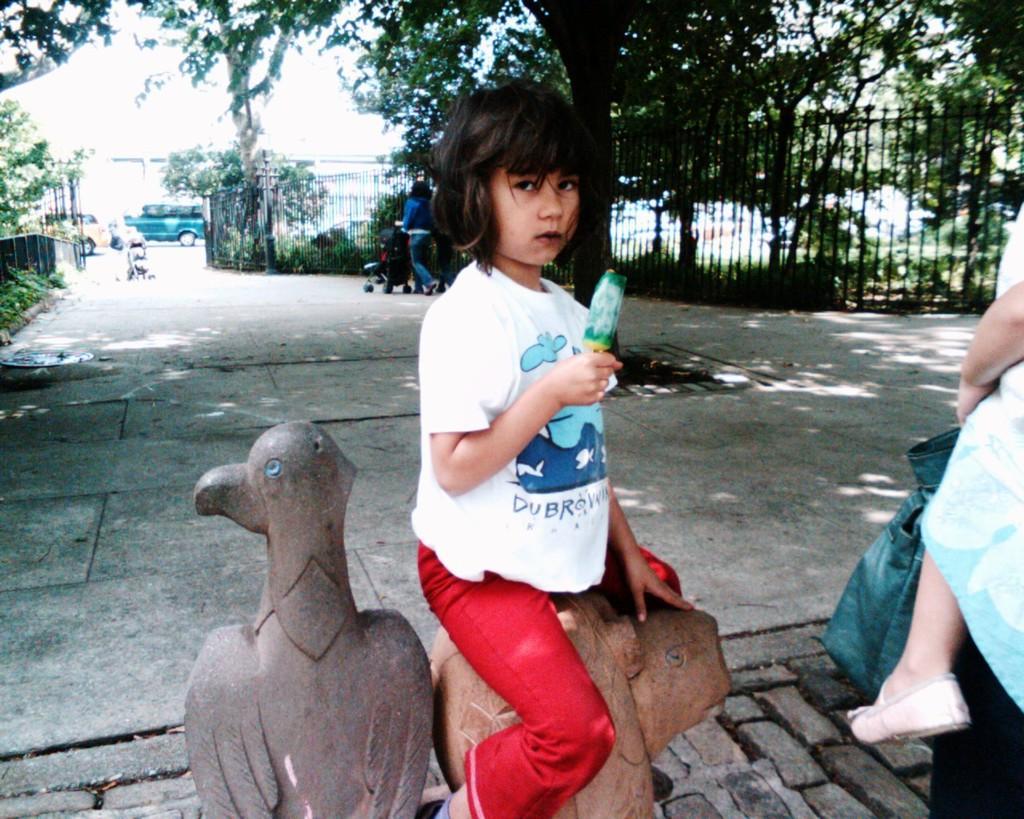Can you describe this image briefly? In this image we can see persons walking on the road and holding baby prams, children sitting on the statues, grills, trees, shrubs, motor vehicles and sky. 